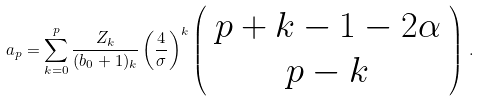<formula> <loc_0><loc_0><loc_500><loc_500>a _ { p } = \sum _ { k = 0 } ^ { p } \frac { Z _ { k } } { ( b _ { 0 } + 1 ) _ { k } } \left ( \frac { 4 } { \sigma } \right ) ^ { k } \left ( \begin{array} { c } p + k - 1 - 2 \alpha \\ p - k \end{array} \right ) \, .</formula> 